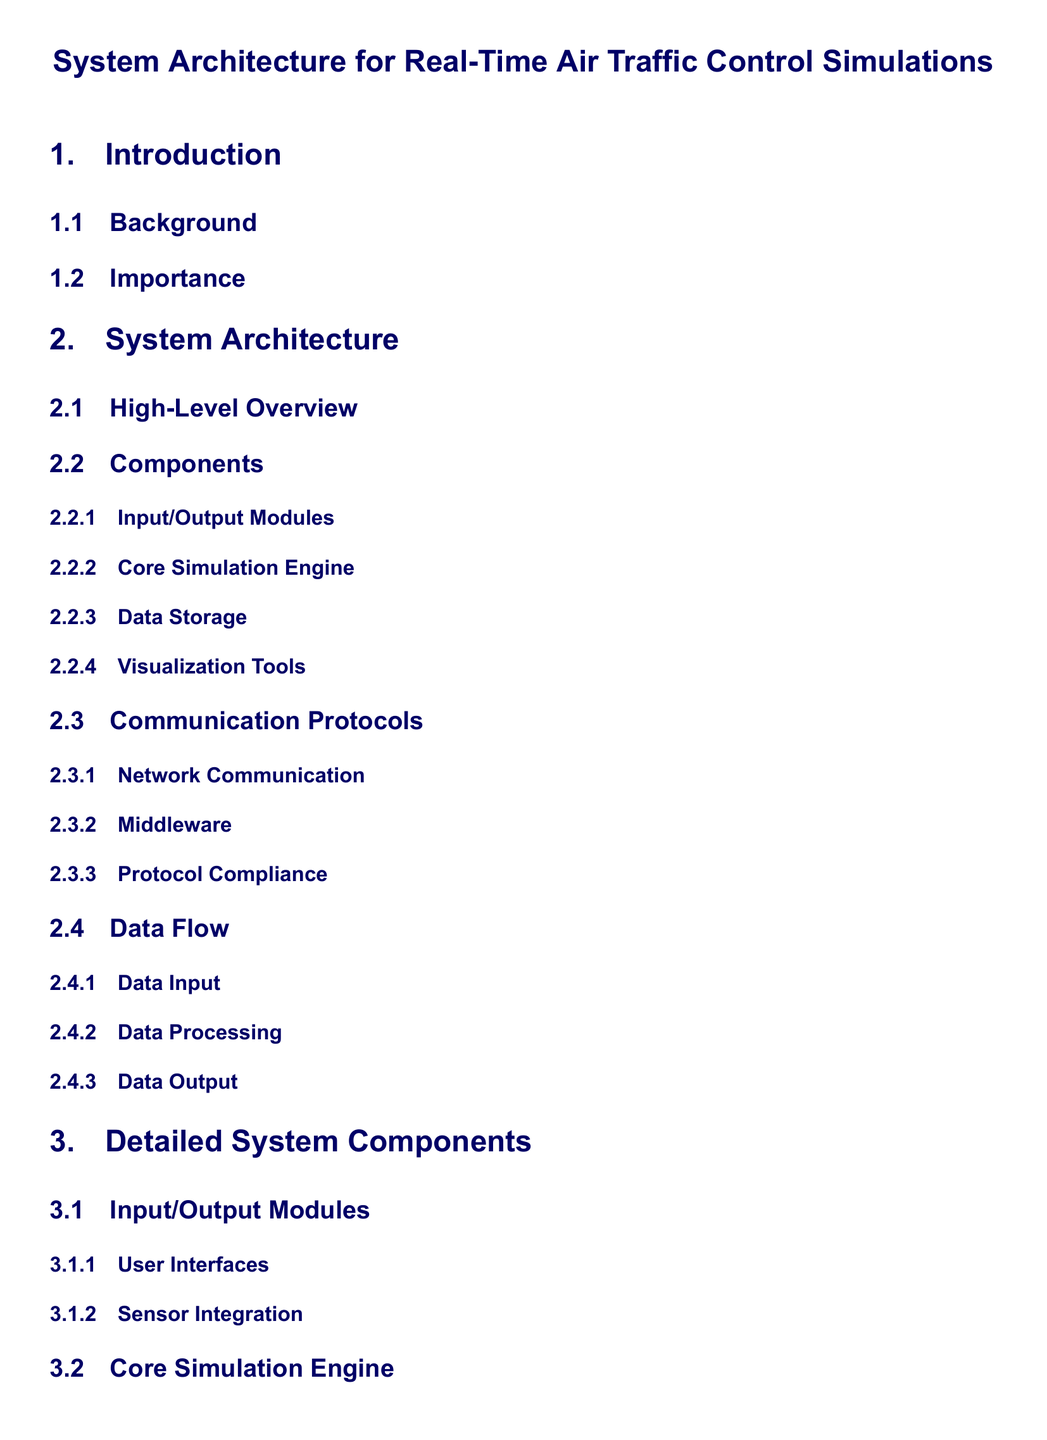What is the title of the document? The title of the document is typically presented at the top of the first page and identifies the main subject matter.
Answer: System Architecture for Real-Time Air Traffic Control Simulations How many main sections are there in the document? The main sections outline the primary topics covered in the document, providing a structured view of the content.
Answer: 4 What is the focus of the "Core Simulation Engine" component? This component is designed to handle the simulations necessary for air traffic control, indicating its pivotal role in the system architecture.
Answer: Aircraft Simulation What type of visualization is mentioned in the "Visualization Tools" section? This term refers to the methods used to display data graphically within the system, crucial for user understanding of the simulations.
Answer: 2D/3D Mapping What is one of the subcategories under "Data Storage"? This subcategory focuses on the systems used to organize and manage the data collected during simulations, which is essential for effective data retrieval.
Answer: Database Systems Which communication protocol is emphasized in "Communication Protocols"? This protocol focuses on how the different components in the system communicate, showcasing the importance of connectivity in a real-time environment.
Answer: Middleware What aspect does the "Data Flow" section describe? This section outlines the path that data takes within the system, illustrating the processes involved from input to output, essential for understanding system operations.
Answer: Data Input What is identified as a crucial future consideration in the document? This aspect deals with potential advancements or improvements that can be made in the system, guiding future development efforts.
Answer: Future Work 